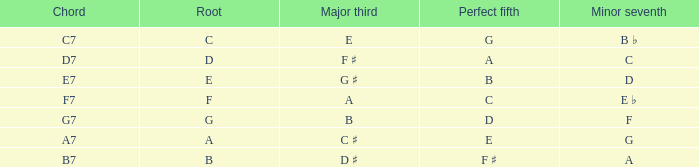What is the perfect quint with a minor that is seventh of d? B. 